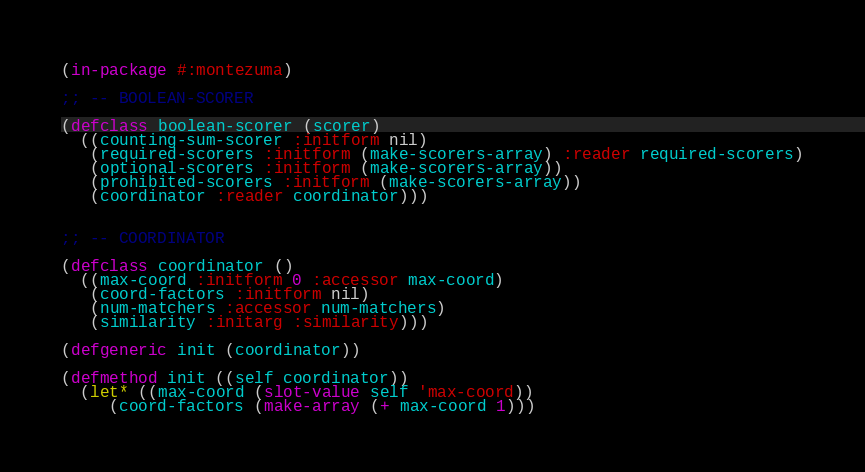Convert code to text. <code><loc_0><loc_0><loc_500><loc_500><_Lisp_>(in-package #:montezuma)

;; -- BOOLEAN-SCORER

(defclass boolean-scorer (scorer)
  ((counting-sum-scorer :initform nil)
   (required-scorers :initform (make-scorers-array) :reader required-scorers)
   (optional-scorers :initform (make-scorers-array))
   (prohibited-scorers :initform (make-scorers-array))
   (coordinator :reader coordinator)))


;; -- COORDINATOR

(defclass coordinator ()
  ((max-coord :initform 0 :accessor max-coord)
   (coord-factors :initform nil)
   (num-matchers :accessor num-matchers)
   (similarity :initarg :similarity)))

(defgeneric init (coordinator))

(defmethod init ((self coordinator))
  (let* ((max-coord (slot-value self 'max-coord))
	 (coord-factors (make-array (+ max-coord 1)))</code> 